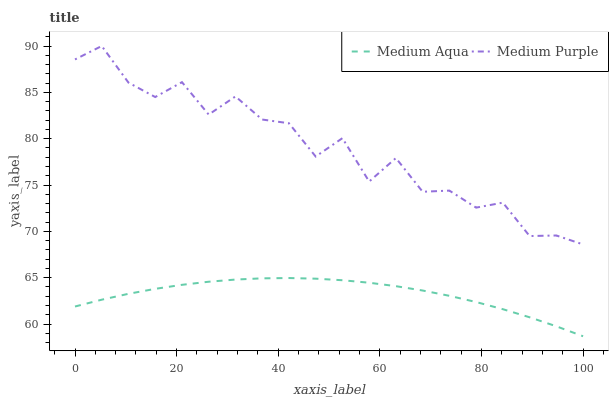Does Medium Aqua have the minimum area under the curve?
Answer yes or no. Yes. Does Medium Purple have the maximum area under the curve?
Answer yes or no. Yes. Does Medium Aqua have the maximum area under the curve?
Answer yes or no. No. Is Medium Aqua the smoothest?
Answer yes or no. Yes. Is Medium Purple the roughest?
Answer yes or no. Yes. Is Medium Aqua the roughest?
Answer yes or no. No. Does Medium Aqua have the lowest value?
Answer yes or no. Yes. Does Medium Purple have the highest value?
Answer yes or no. Yes. Does Medium Aqua have the highest value?
Answer yes or no. No. Is Medium Aqua less than Medium Purple?
Answer yes or no. Yes. Is Medium Purple greater than Medium Aqua?
Answer yes or no. Yes. Does Medium Aqua intersect Medium Purple?
Answer yes or no. No. 